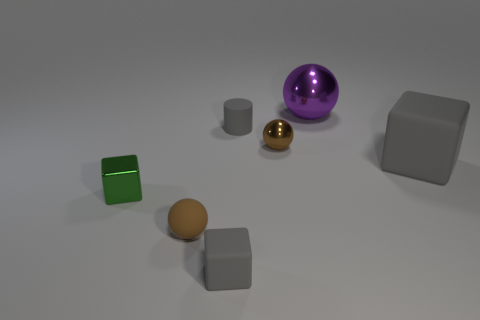Add 2 small brown matte things. How many objects exist? 9 Subtract all cylinders. How many objects are left? 6 Subtract 0 cyan balls. How many objects are left? 7 Subtract all tiny brown matte objects. Subtract all rubber blocks. How many objects are left? 4 Add 2 small green metal cubes. How many small green metal cubes are left? 3 Add 5 matte balls. How many matte balls exist? 6 